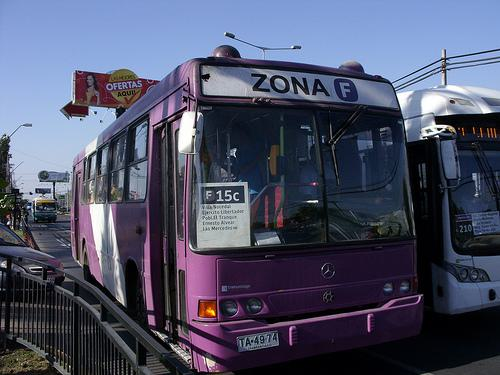What does the sign on the bus indicate about its route or destination? The bus has a sign indicating '15c', which is likely a route number, and 'J.J. Perez' which could be the name of the final stop, a key location on the route, or the street it services. The 'Zona F' marking suggests the bus operates within a specific sector or zone of a larger transit network. 